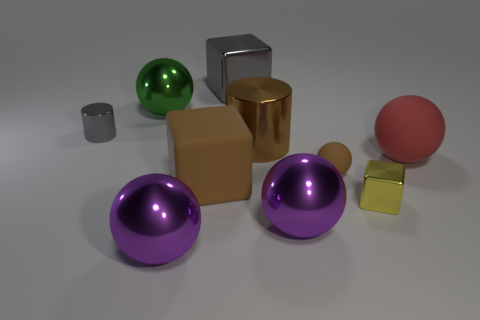How many metal things are either tiny yellow cylinders or tiny spheres?
Give a very brief answer. 0. What shape is the big matte thing on the left side of the cube that is on the right side of the large cylinder?
Give a very brief answer. Cube. Is the number of large red spheres that are in front of the large brown cylinder less than the number of gray cubes?
Provide a short and direct response. No. What shape is the red matte object?
Your answer should be very brief. Sphere. There is a shiny block right of the small rubber thing; how big is it?
Your response must be concise. Small. What color is the rubber thing that is the same size as the matte block?
Keep it short and to the point. Red. Are there any metal objects that have the same color as the small cylinder?
Offer a very short reply. Yes. Is the number of tiny balls to the right of the small yellow metal cube less than the number of large shiny objects that are behind the tiny shiny cylinder?
Make the answer very short. Yes. There is a small object that is on the left side of the small yellow metal object and to the right of the big green object; what material is it made of?
Offer a terse response. Rubber. Do the tiny rubber thing and the large purple shiny object right of the big brown matte block have the same shape?
Your response must be concise. Yes. 